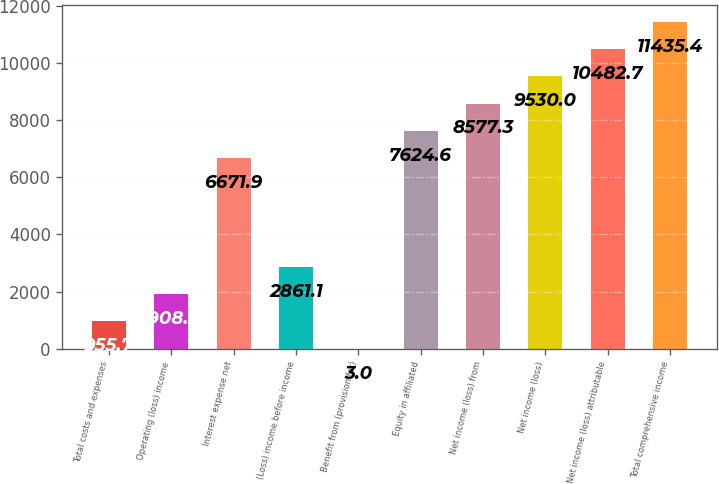Convert chart. <chart><loc_0><loc_0><loc_500><loc_500><bar_chart><fcel>Total costs and expenses<fcel>Operating (loss) income<fcel>Interest expense net<fcel>(Loss) income before income<fcel>Benefit from (provision for)<fcel>Equity in affiliated<fcel>Net income (loss) from<fcel>Net income (loss)<fcel>Net income (loss) attributable<fcel>Total comprehensive income<nl><fcel>955.7<fcel>1908.4<fcel>6671.9<fcel>2861.1<fcel>3<fcel>7624.6<fcel>8577.3<fcel>9530<fcel>10482.7<fcel>11435.4<nl></chart> 